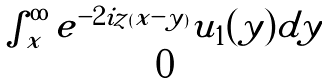Convert formula to latex. <formula><loc_0><loc_0><loc_500><loc_500>\begin{matrix} \int _ { x } ^ { \infty } e ^ { - 2 i z ( x - y ) } u _ { 1 } ( y ) d y \\ 0 \end{matrix}</formula> 